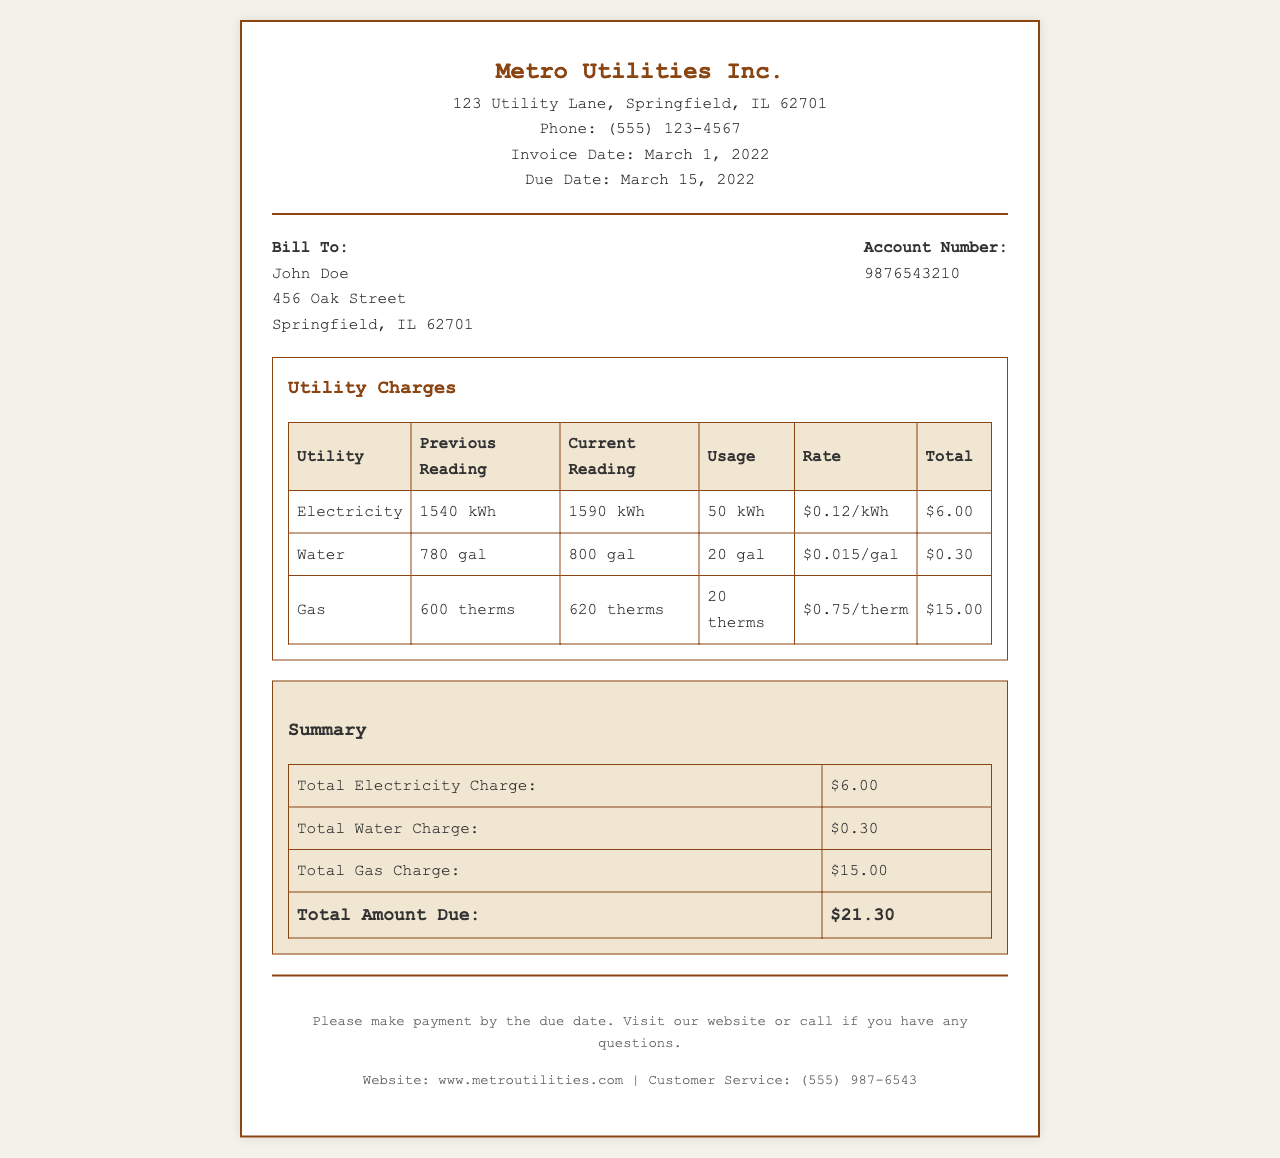What is the invoice date? The invoice date is clearly labeled in the document as the date when the invoice was generated, which is March 1, 2022.
Answer: March 1, 2022 What is the total amount due? The total amount due can be found in the summary section of the document, indicating the total of all utility charges.
Answer: $21.30 How much was charged for gas? The total gas charge is presented in the summary table as the specific amount charged for gas usage.
Answer: $15.00 What is the account number? The account number assigned to the billing recipient is explicitly provided in the billing information section of the document.
Answer: 9876543210 How many kilowatt hours were used for electricity? The usage for electricity is detailed in the utility charges table, showing the difference between the current and previous reading.
Answer: 50 kWh What is the rate per gallon for water? The rate for water usage is mentioned in the utility charges table, providing the cost per gallon.
Answer: $0.015/gal What company issued this invoice? The document starts with the name of the issuing company, indicating who the invoice is from.
Answer: Metro Utilities Inc What was the previous reading for gas? The previous reading for gas is included in the utility charges table, showing the amount before current usage was measured.
Answer: 600 therms When is the payment due? The due date for payment is mentioned in the document, indicating the last date for the payment to be made.
Answer: March 15, 2022 